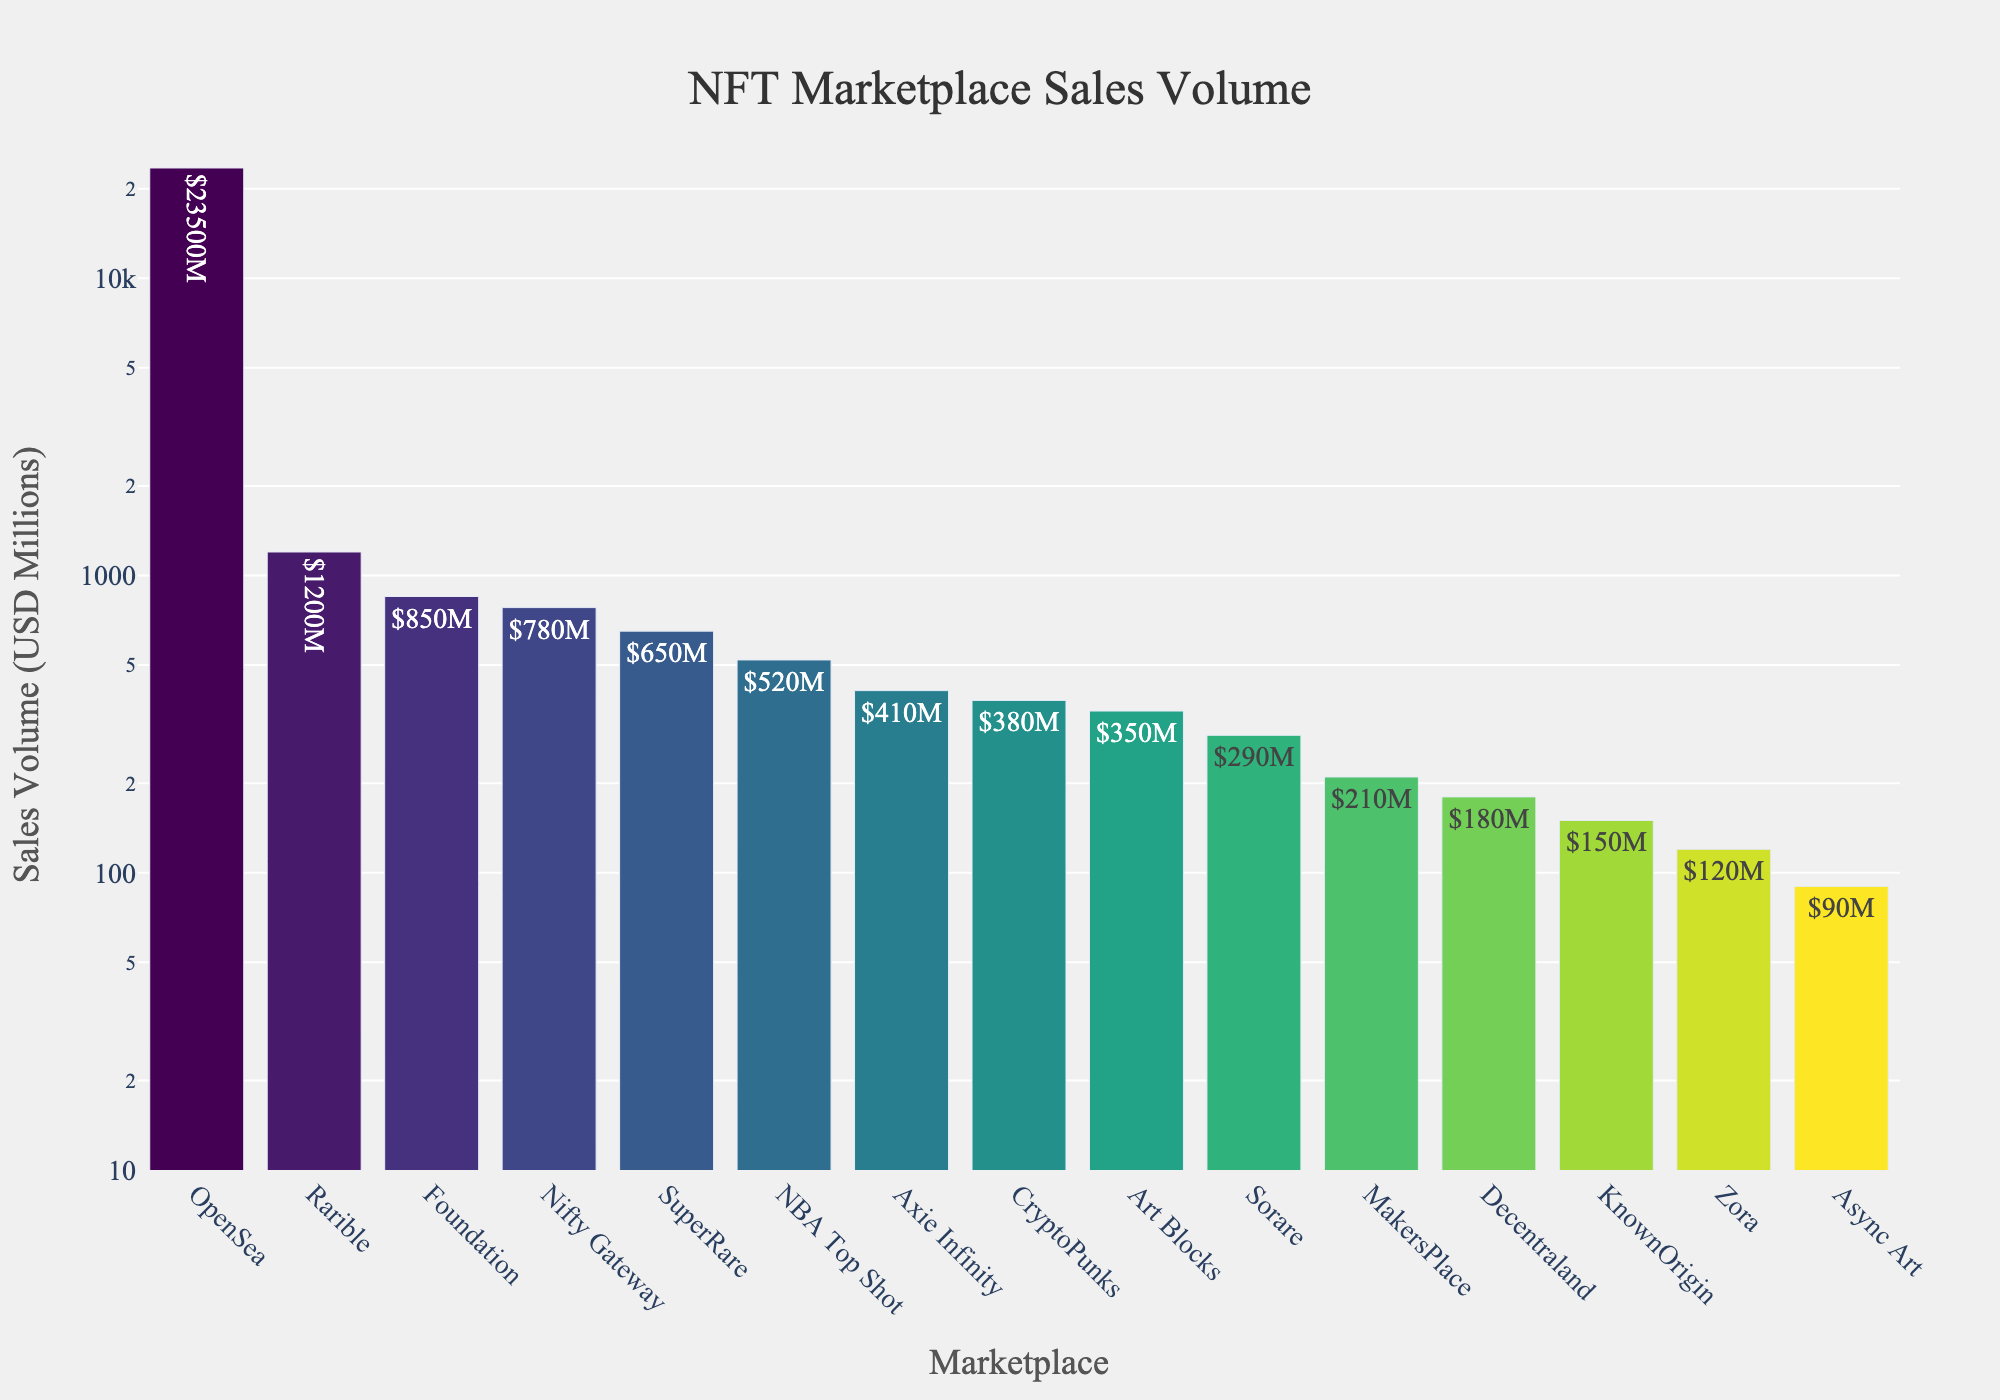What's the marketplace with the highest sales volume? The marketplace with the highest bar in the chart represents the marketplace with the highest sales volume. The bar for OpenSea is the highest.
Answer: OpenSea Which marketplaces have sales volumes greater than $1000M? To determine this, identify the bars that correspond to sales volumes above $1000M. The bars for OpenSea and Rarible are the only ones above this threshold.
Answer: OpenSea, Rarible What is the sum of sales volumes for Foundation and SuperRare? Find the sales volumes for Foundation ($850M) and SuperRare ($650M), then add them together: $850M + $650M.
Answer: $1500M How does the sales volume of Nifty Gateway compare to Foundation? Compare the heights of the bars for Nifty Gateway ($780M) and Foundation ($850M). The bar for Foundation is slightly taller.
Answer: Foundation is higher Which marketplace has the second lowest sales volume? Order the marketplaces by their bar heights in ascending order. The second-shortest bar corresponds to Async Art with a sales volume of $90M.
Answer: Async Art What is the average sales volume of the top three marketplaces? Identify the top three marketplaces by bar height: OpenSea ($23500M), Rarible ($1200M), and Foundation ($850M). Then calculate the average: ($23500M + $1200M + $850M) / 3.
Answer: $8523.33M Is the sales volume of CryptoPunks more than double that of Axie Infinity? Identify the sales volumes of CryptoPunks ($380M) and Axie Infinity ($410M), and multiply Axie Infinity's sales volume by 2. Compare this with CryptoPunks' sales volume: 2 * $410M = $820M; $380M < $820M.
Answer: No How many marketplaces have sales volumes below $500M? Count the number of bars that represent sales volumes less than $500M. These are SuperRare, NBA Top Shot, Axie Infinity, CryptoPunks, Art Blocks, Sorare, MakersPlace, Decentraland, KnownOrigin, Zora, and Async Art. Total is 11 bars.
Answer: 11 Which marketplace's sales volume is closest to $500M? Look at the bars near the $500M mark on the y-axis. The sales volumes close to $500M are NBA Top Shot ($520M).
Answer: NBA Top Shot 